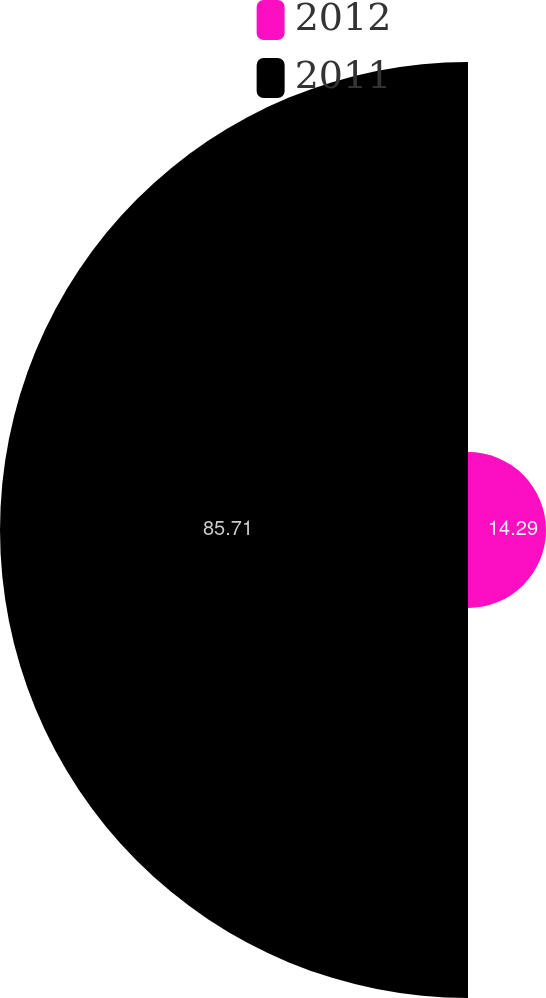Convert chart to OTSL. <chart><loc_0><loc_0><loc_500><loc_500><pie_chart><fcel>2012<fcel>2011<nl><fcel>14.29%<fcel>85.71%<nl></chart> 